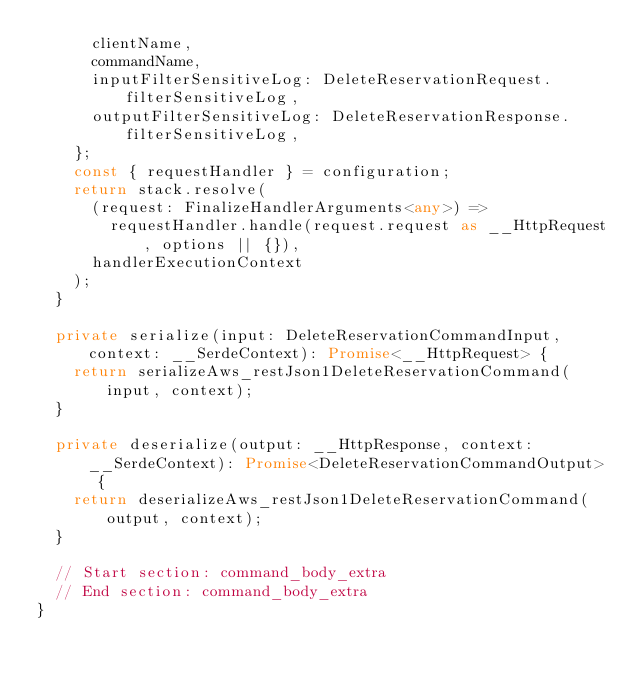Convert code to text. <code><loc_0><loc_0><loc_500><loc_500><_TypeScript_>      clientName,
      commandName,
      inputFilterSensitiveLog: DeleteReservationRequest.filterSensitiveLog,
      outputFilterSensitiveLog: DeleteReservationResponse.filterSensitiveLog,
    };
    const { requestHandler } = configuration;
    return stack.resolve(
      (request: FinalizeHandlerArguments<any>) =>
        requestHandler.handle(request.request as __HttpRequest, options || {}),
      handlerExecutionContext
    );
  }

  private serialize(input: DeleteReservationCommandInput, context: __SerdeContext): Promise<__HttpRequest> {
    return serializeAws_restJson1DeleteReservationCommand(input, context);
  }

  private deserialize(output: __HttpResponse, context: __SerdeContext): Promise<DeleteReservationCommandOutput> {
    return deserializeAws_restJson1DeleteReservationCommand(output, context);
  }

  // Start section: command_body_extra
  // End section: command_body_extra
}
</code> 